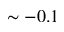Convert formula to latex. <formula><loc_0><loc_0><loc_500><loc_500>\sim - 0 . 1</formula> 